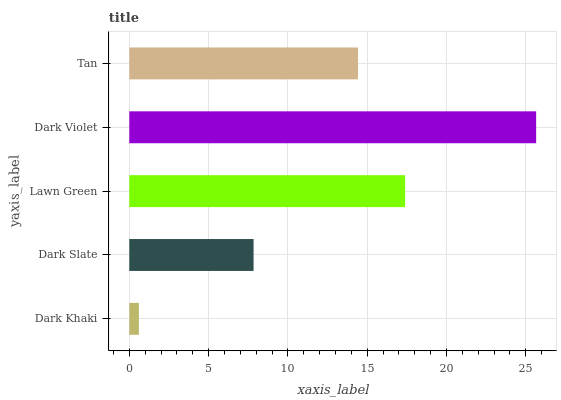Is Dark Khaki the minimum?
Answer yes or no. Yes. Is Dark Violet the maximum?
Answer yes or no. Yes. Is Dark Slate the minimum?
Answer yes or no. No. Is Dark Slate the maximum?
Answer yes or no. No. Is Dark Slate greater than Dark Khaki?
Answer yes or no. Yes. Is Dark Khaki less than Dark Slate?
Answer yes or no. Yes. Is Dark Khaki greater than Dark Slate?
Answer yes or no. No. Is Dark Slate less than Dark Khaki?
Answer yes or no. No. Is Tan the high median?
Answer yes or no. Yes. Is Tan the low median?
Answer yes or no. Yes. Is Lawn Green the high median?
Answer yes or no. No. Is Dark Slate the low median?
Answer yes or no. No. 